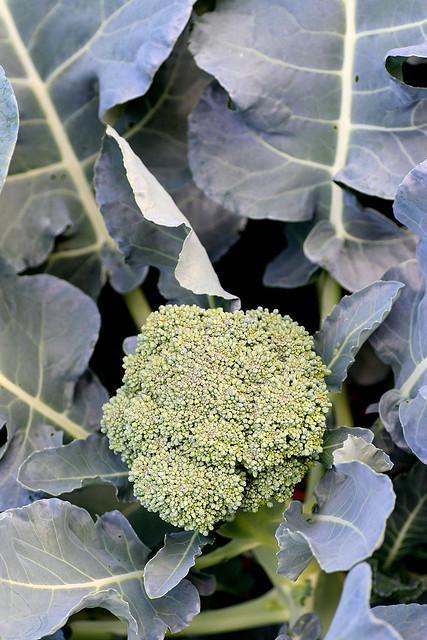How many cars have zebra stripes?
Give a very brief answer. 0. 